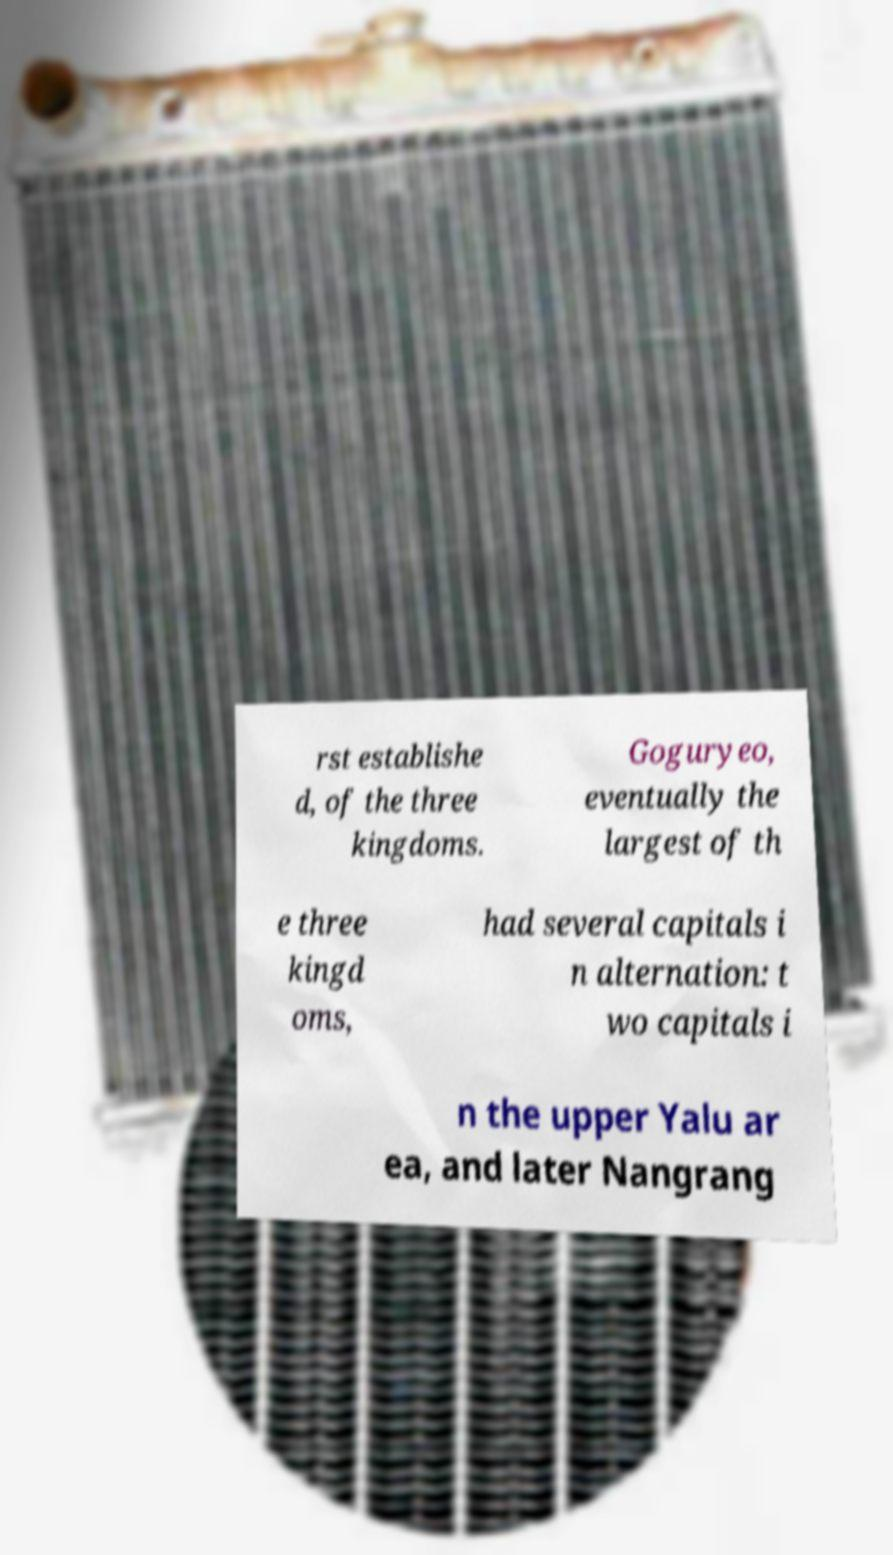Please read and relay the text visible in this image. What does it say? rst establishe d, of the three kingdoms. Goguryeo, eventually the largest of th e three kingd oms, had several capitals i n alternation: t wo capitals i n the upper Yalu ar ea, and later Nangrang 